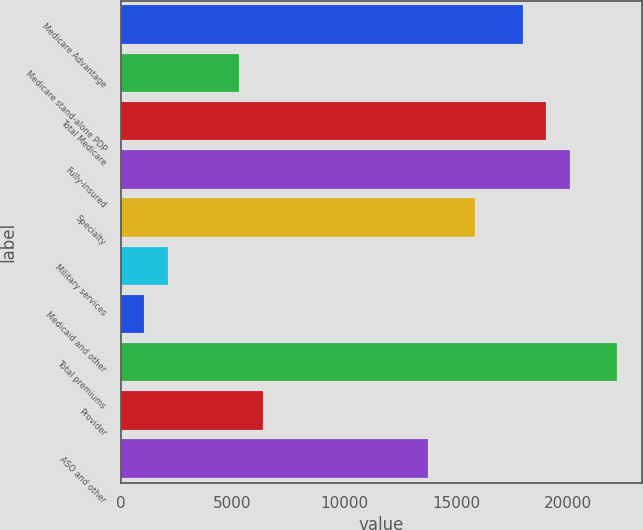<chart> <loc_0><loc_0><loc_500><loc_500><bar_chart><fcel>Medicare Advantage<fcel>Medicare stand-alone PDP<fcel>Total Medicare<fcel>Fully-insured<fcel>Specialty<fcel>Military services<fcel>Medicaid and other<fcel>Total premiums<fcel>Provider<fcel>ASO and other<nl><fcel>17987.5<fcel>5290.64<fcel>19045.5<fcel>20103.6<fcel>15871.3<fcel>2116.43<fcel>1058.36<fcel>22219.8<fcel>6348.71<fcel>13755.2<nl></chart> 